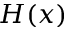<formula> <loc_0><loc_0><loc_500><loc_500>H ( x )</formula> 